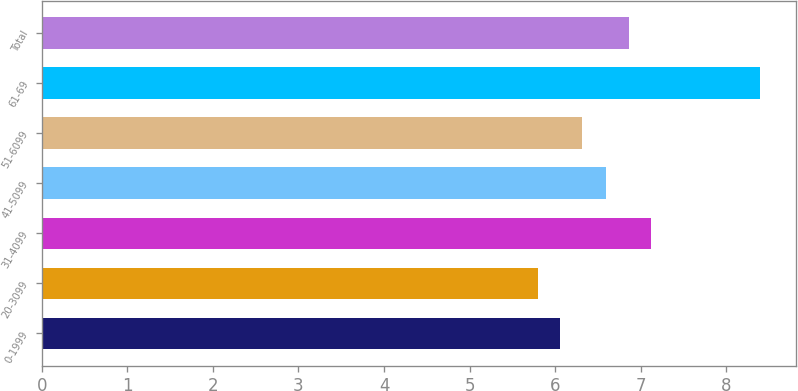Convert chart. <chart><loc_0><loc_0><loc_500><loc_500><bar_chart><fcel>0-1999<fcel>20-3099<fcel>31-4099<fcel>41-5099<fcel>51-6099<fcel>61-69<fcel>Total<nl><fcel>6.06<fcel>5.8<fcel>7.12<fcel>6.6<fcel>6.32<fcel>8.4<fcel>6.86<nl></chart> 